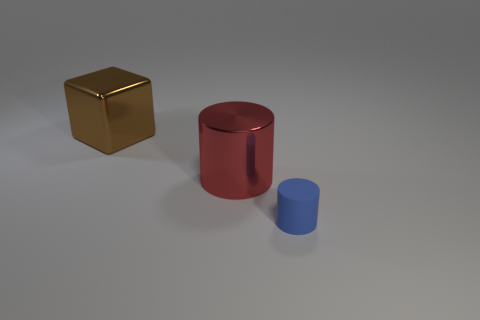Add 1 large purple rubber cubes. How many objects exist? 4 Subtract all blue cylinders. How many cylinders are left? 1 Subtract all cylinders. How many objects are left? 1 Subtract 1 cylinders. How many cylinders are left? 1 Subtract all blue cubes. Subtract all cyan cylinders. How many cubes are left? 1 Subtract all gray shiny blocks. Subtract all large brown metallic cubes. How many objects are left? 2 Add 1 brown metallic things. How many brown metallic things are left? 2 Add 2 brown metallic cubes. How many brown metallic cubes exist? 3 Subtract 0 yellow cylinders. How many objects are left? 3 